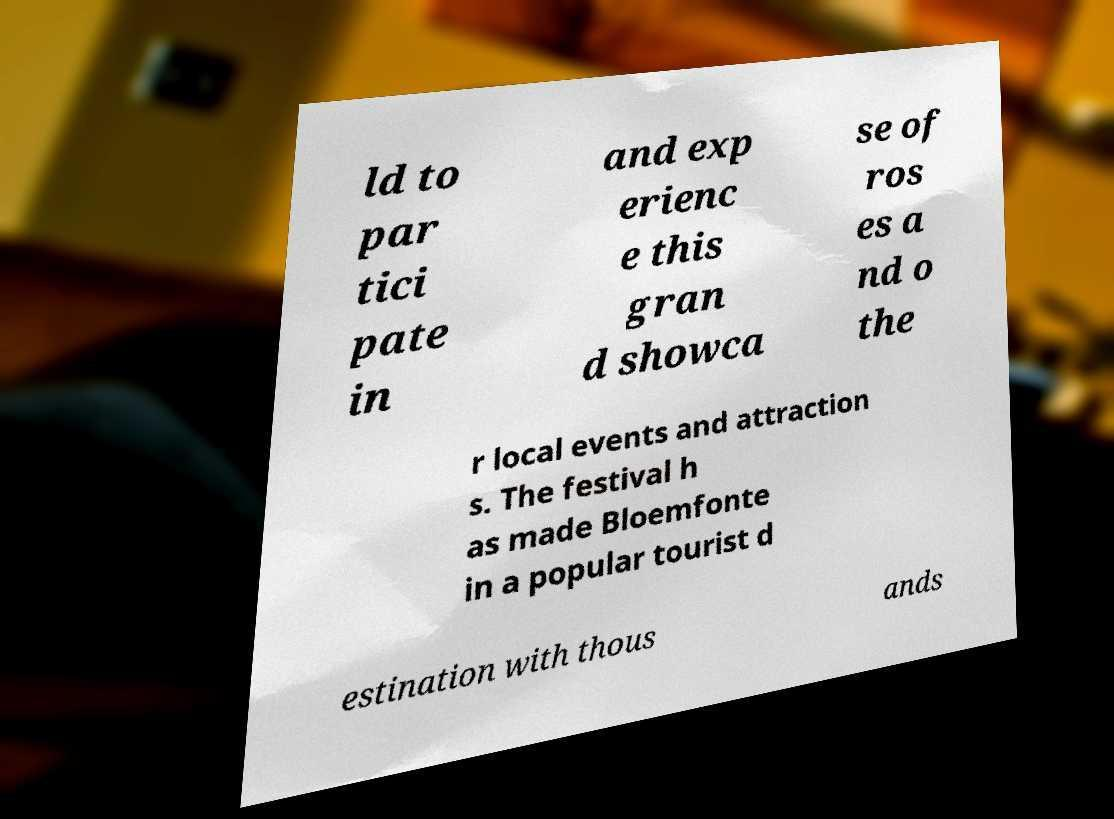Could you assist in decoding the text presented in this image and type it out clearly? ld to par tici pate in and exp erienc e this gran d showca se of ros es a nd o the r local events and attraction s. The festival h as made Bloemfonte in a popular tourist d estination with thous ands 